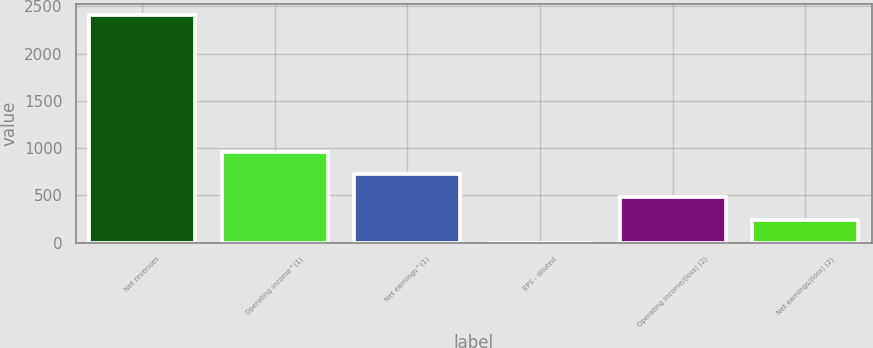<chart> <loc_0><loc_0><loc_500><loc_500><bar_chart><fcel>Net revenues<fcel>Operating income^(1)<fcel>Net earnings^(1)<fcel>EPS - diluted<fcel>Operating income/(loss) (2)<fcel>Net earnings/(loss) (2)<nl><fcel>2403.9<fcel>961.68<fcel>721.31<fcel>0.2<fcel>480.94<fcel>240.57<nl></chart> 